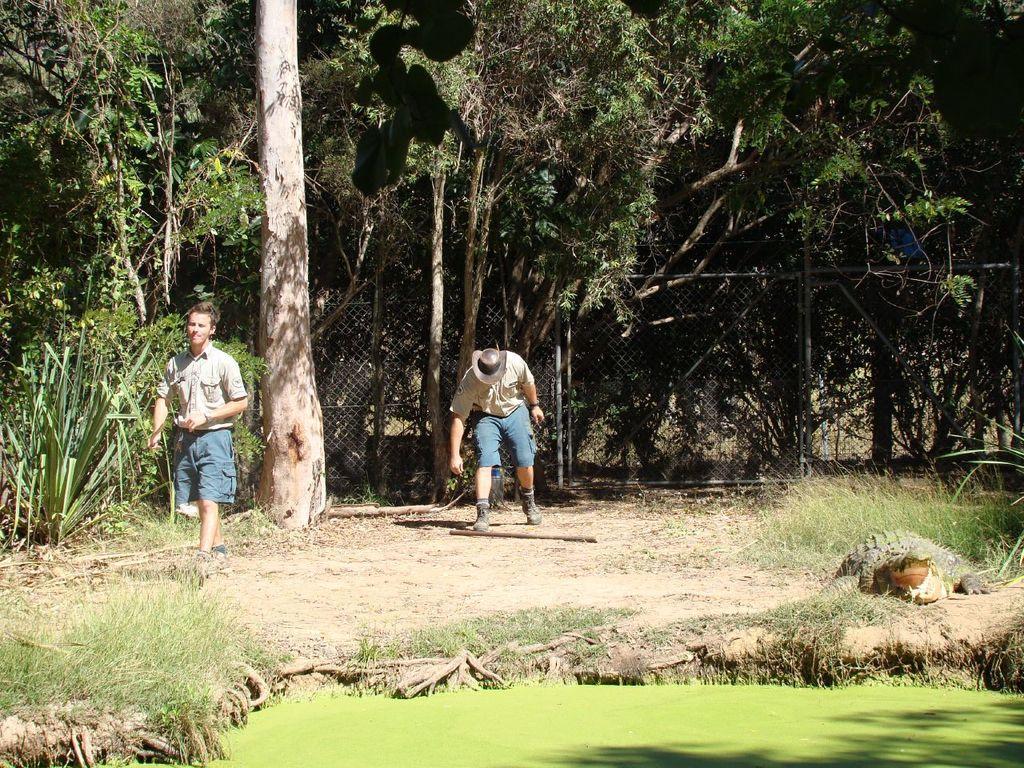Can you describe this image briefly? In the image there are two men and around them there are trees, grass and plants. 